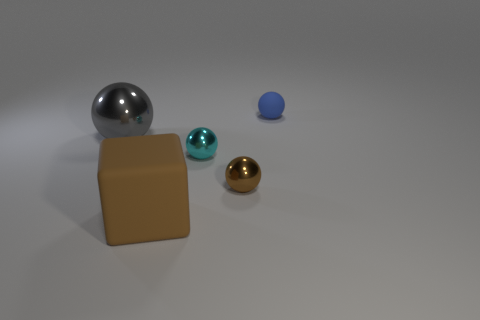Add 4 matte spheres. How many objects exist? 9 Subtract all balls. How many objects are left? 1 Subtract 0 blue cylinders. How many objects are left? 5 Subtract all large brown metal cubes. Subtract all cyan balls. How many objects are left? 4 Add 1 blue balls. How many blue balls are left? 2 Add 5 blue metallic cubes. How many blue metallic cubes exist? 5 